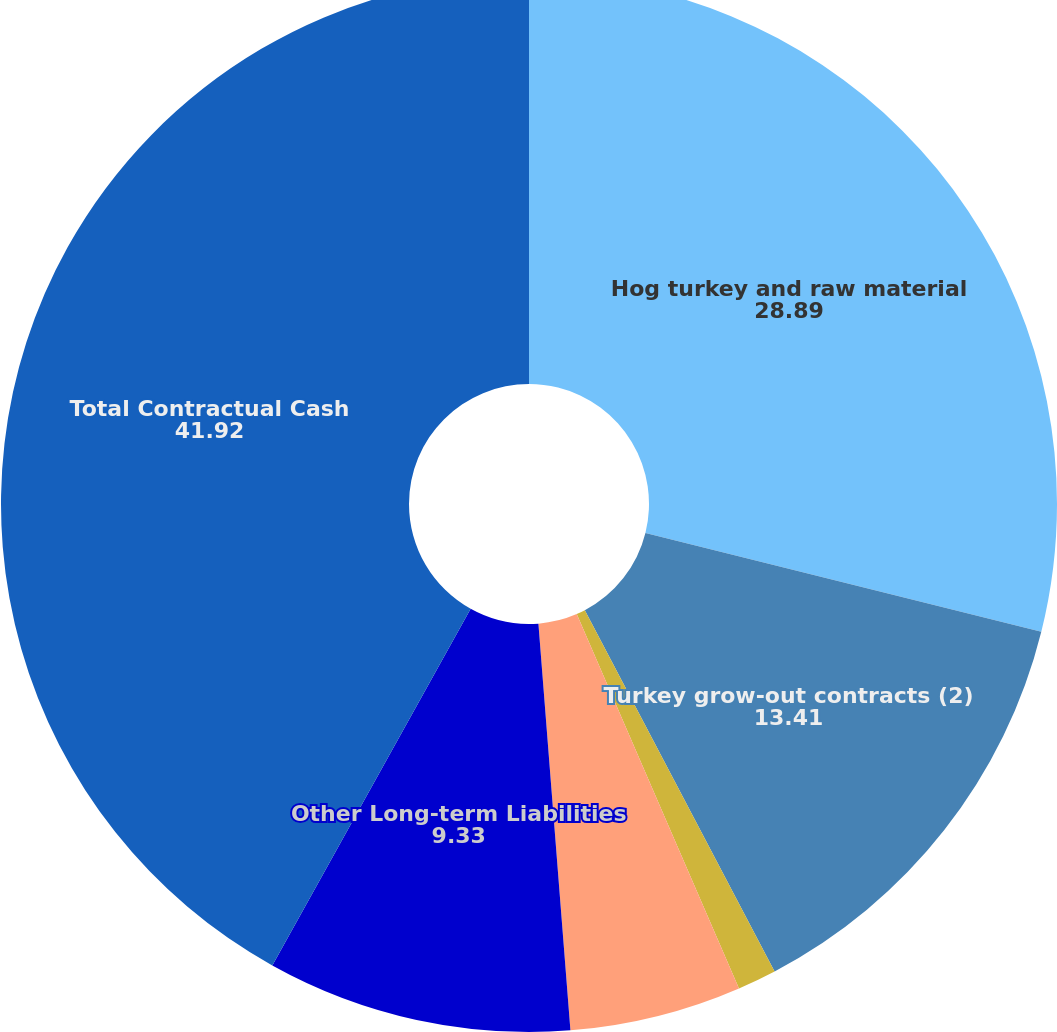Convert chart to OTSL. <chart><loc_0><loc_0><loc_500><loc_500><pie_chart><fcel>Hog turkey and raw material<fcel>Turkey grow-out contracts (2)<fcel>Capital Leases<fcel>Operating Leases<fcel>Other Long-term Liabilities<fcel>Total Contractual Cash<nl><fcel>28.89%<fcel>13.41%<fcel>1.19%<fcel>5.26%<fcel>9.33%<fcel>41.92%<nl></chart> 